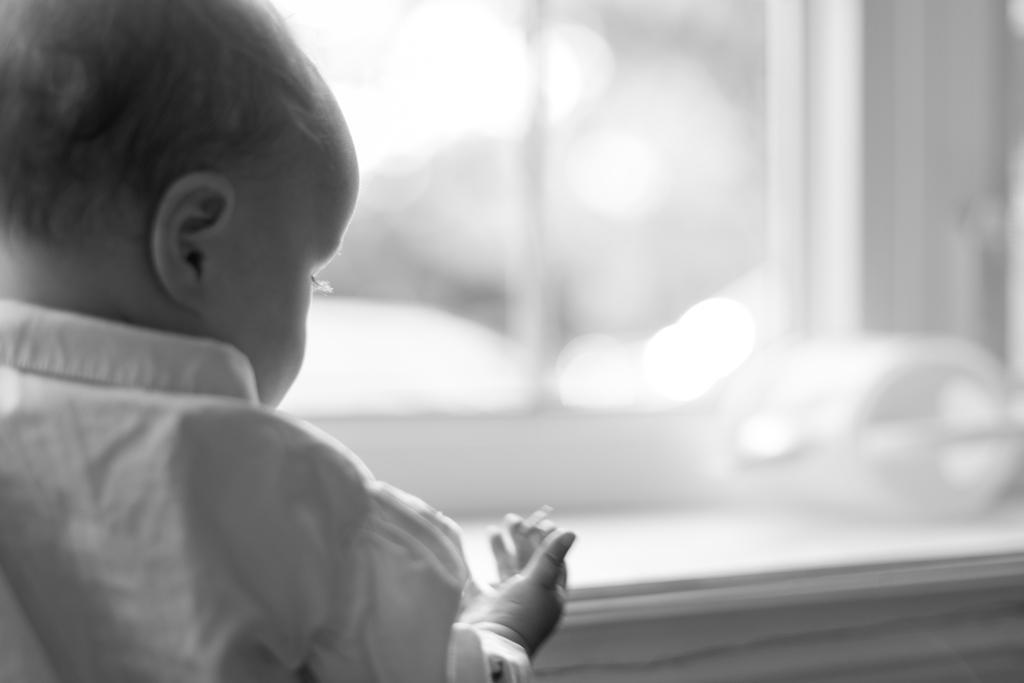Please provide a concise description of this image. In this picture I can observe a baby on the left side. The background is completely blurred. This is a black and white image. 